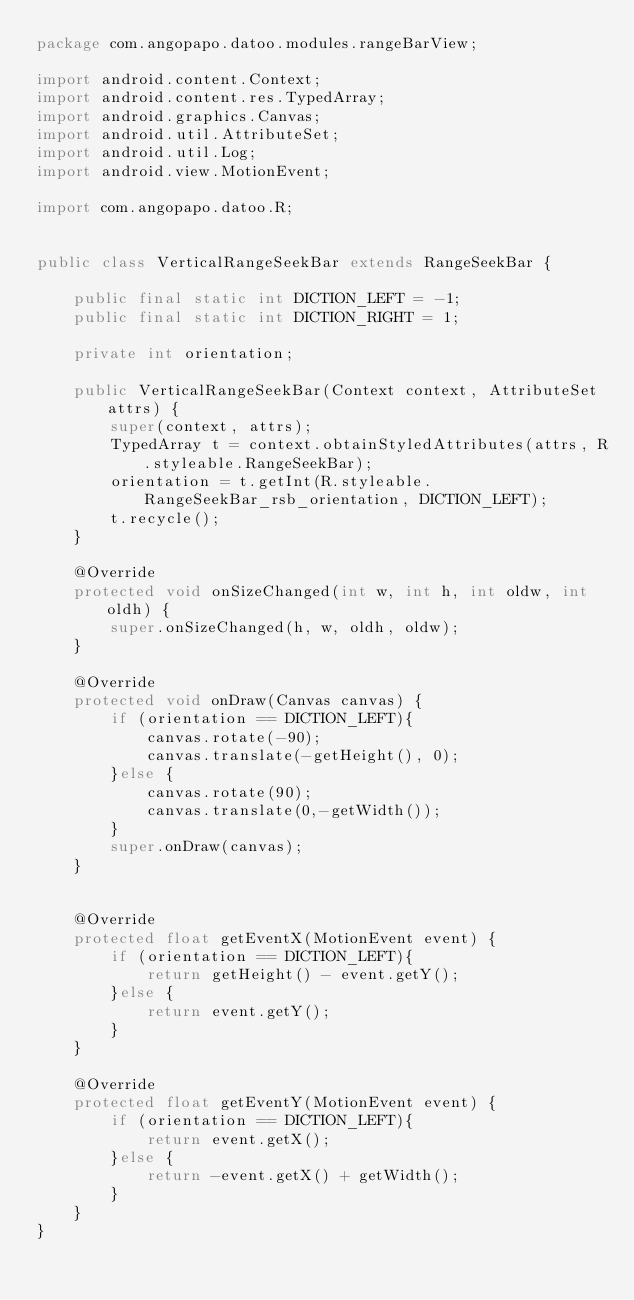Convert code to text. <code><loc_0><loc_0><loc_500><loc_500><_Java_>package com.angopapo.datoo.modules.rangeBarView;

import android.content.Context;
import android.content.res.TypedArray;
import android.graphics.Canvas;
import android.util.AttributeSet;
import android.util.Log;
import android.view.MotionEvent;

import com.angopapo.datoo.R;


public class VerticalRangeSeekBar extends RangeSeekBar {

    public final static int DICTION_LEFT = -1;
    public final static int DICTION_RIGHT = 1;

    private int orientation;

    public VerticalRangeSeekBar(Context context, AttributeSet attrs) {
        super(context, attrs);
        TypedArray t = context.obtainStyledAttributes(attrs, R.styleable.RangeSeekBar);
        orientation = t.getInt(R.styleable.RangeSeekBar_rsb_orientation, DICTION_LEFT);
        t.recycle();
    }

    @Override
    protected void onSizeChanged(int w, int h, int oldw, int oldh) {
        super.onSizeChanged(h, w, oldh, oldw);
    }

    @Override
    protected void onDraw(Canvas canvas) {
        if (orientation == DICTION_LEFT){
            canvas.rotate(-90);
            canvas.translate(-getHeight(), 0);
        }else {
            canvas.rotate(90);
            canvas.translate(0,-getWidth());
        }
        super.onDraw(canvas);
    }


    @Override
    protected float getEventX(MotionEvent event) {
        if (orientation == DICTION_LEFT){
            return getHeight() - event.getY();
        }else {
            return event.getY();
        }
    }

    @Override
    protected float getEventY(MotionEvent event) {
        if (orientation == DICTION_LEFT){
            return event.getX();
        }else {
            return -event.getX() + getWidth();
        }
    }
}
</code> 